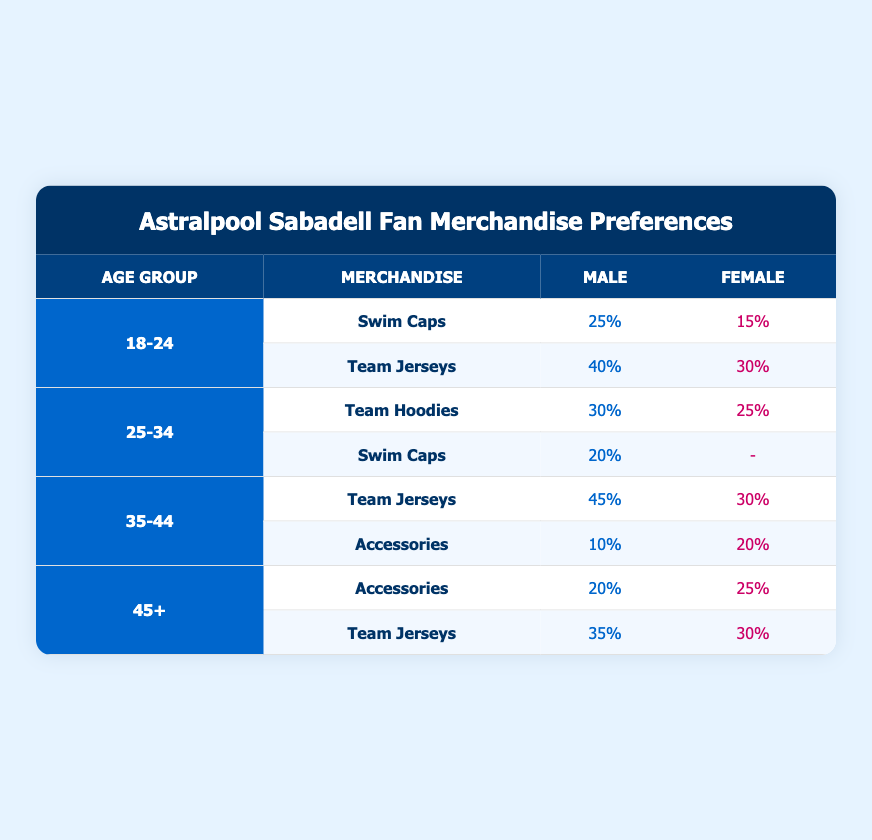What is the highest merchandise preference percentage for males in the 18-24 age group? The table shows that males in the 18-24 age group have a preference percentage of 40% for Team Jerseys, which is the highest percentage in that group.
Answer: 40% Which merchandise has the lowest preference among females aged 25-34? According to the table, females in the 25-34 age group show no preference for Swim Caps, denoted by a "-". Thus, Swim Caps have the lowest preference for this group.
Answer: Swim Caps What is the combined preference percentage for Team Jerseys among males in the 35-44 and 45+ age groups? Males aged 35-44 have a preference percentage of 45% for Team Jerseys, and males aged 45+ have 35%. Summing these gives 45% + 35% = 80%.
Answer: 80% Is the preference for Team Hoodies higher among males or females in the 25-34 age group? Males show a preference percentage of 30% for Team Hoodies, while females have a 25% preference. Since 30% is greater than 25%, males have a higher preference for Team Hoodies.
Answer: Yes What is the average preference percentage for Accessories among females across all age groups? The preference percentages for females are 20% (35-44) and 25% (45+), which gives us (20% + 25%) / 2 = 22.5%. There are no percentages for the 18-24 and 25-34 age groups for Accessories, so we only consider these two.
Answer: 22.5% 